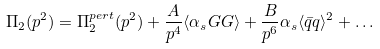Convert formula to latex. <formula><loc_0><loc_0><loc_500><loc_500>\Pi _ { 2 } ( p ^ { 2 } ) = \Pi _ { 2 } ^ { p e r t } ( p ^ { 2 } ) + \frac { A } { p ^ { 4 } } \langle \alpha _ { s } G G \rangle + \frac { B } { p ^ { 6 } } \alpha _ { s } \langle \bar { q } q \rangle ^ { 2 } + \dots</formula> 